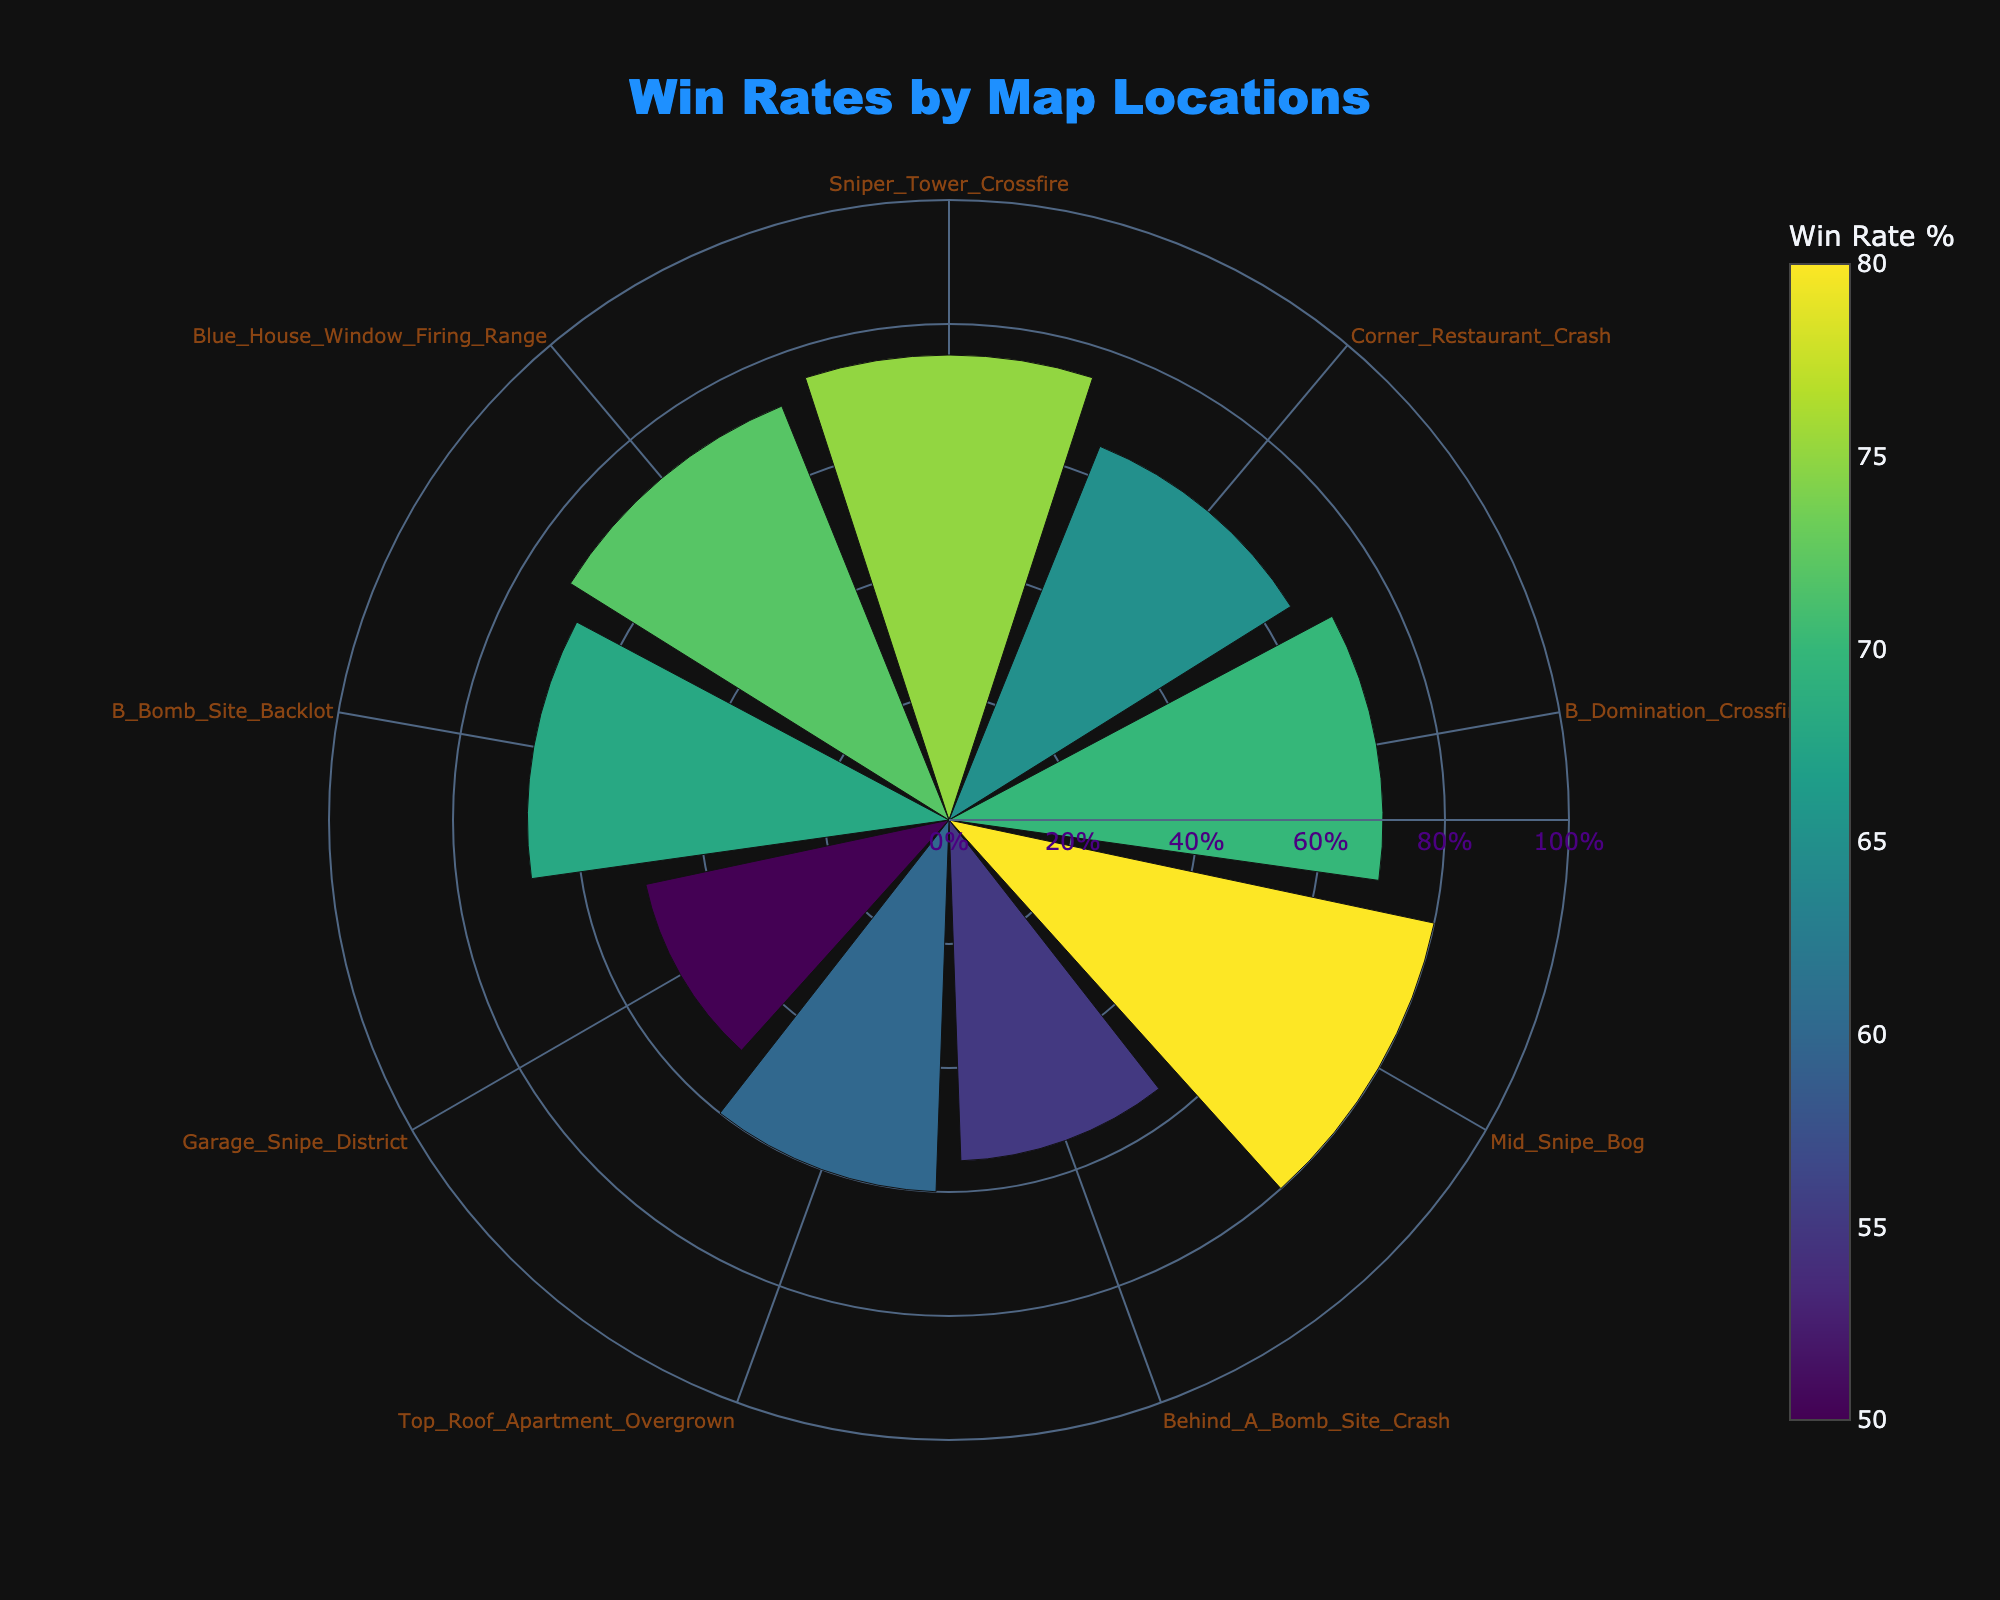Which cheat spot has the highest win rate? The chart displays win rates by cheat spot locations. The highest radial length indicates the highest win rate. Based on the radial bars, the 'Mid_Snipe_Bog' spot reaches the highest point.
Answer: 'Mid_Snipe_Bog' What is the win rate at the 'Corner_Restaurant_Crash' spot? The chart shows individual win rates at each cheat spot by radial length. The radial bar labeled 'Corner_Restaurant_Crash' shows a win rate of 65%.
Answer: 65% How many cheat spots have win rates higher than 65%? To find this, count the number of bars extending beyond the 65% radial mark. The spots with win rates higher than 65% are 'Sniper_Tower_Crossfire', 'B_Domination_Crossfire', 'Mid_Snipe_Bog', and 'Blue_House_Window_Firing_Range'.
Answer: 4 Which cheat spot has a lower win rate: 'Garage_Snipe_District' or 'Top_Roof_Apartment_Overgrown'? Compare the radial lengths of 'Garage_Snipe_District' (50%) and 'Top_Roof_Apartment_Overgrown' (60%). The bar height of 'Garage_Snipe_District' is shorter.
Answer: 'Garage_Snipe_District' What is the average win rate of all the cheat spots? Sum the win rates and divide by the total number of spots: (75 + 65 + 70 + 80 + 55 + 60 + 50 + 68 + 72) / 9 = 595 / 9 = 66.11%.
Answer: 66.11% Which cheat spots fall into the bottom 3 win rates? Identify the three shortest radial bars. The lowest win rates are at 'Garage_Snipe_District' (50%), 'Behind_A_Bomb_Site_Crash' (55%), and 'Top_Roof_Apartment_Overgrown' (60%).
Answer: 'Garage_Snipe_District', 'Behind_A_Bomb_Site_Crash', 'Top_Roof_Apartment_Overgrown' Is the win rate at 'B_Bomb_Site_Backlot' higher or lower than the average win rate? The average win rate is approximately 66.11%. Comparing this with the win rate at 'B_Bomb_Site_Backlot' (68%), the value is higher.
Answer: Higher Which cheat spot shows the second highest win rate? After 'Mid_Snipe_Bog' (80%), identify the next-highest radial bar. The second highest is 'Sniper_Tower_Crossfire' (75%).
Answer: 'Sniper_Tower_Crossfire' What would be the median win rate of these cheat spots? Organize the win rates in ascending order (50, 55, 60, 65, 68, 70, 72, 75, 80). The middle value in the ordered list is 68%.
Answer: 68% Compare the win rates between the cheat spots 'B_Domination_Crossfire' and 'Blue_House_Window_Firing_Range'. Which has the higher rate? Check the radial bars for 'B_Domination_Crossfire' (70%) and 'Blue_House_Window_Firing_Range' (72%). The latter is slightly higher.
Answer: 'Blue_House_Window_Firing_Range' 